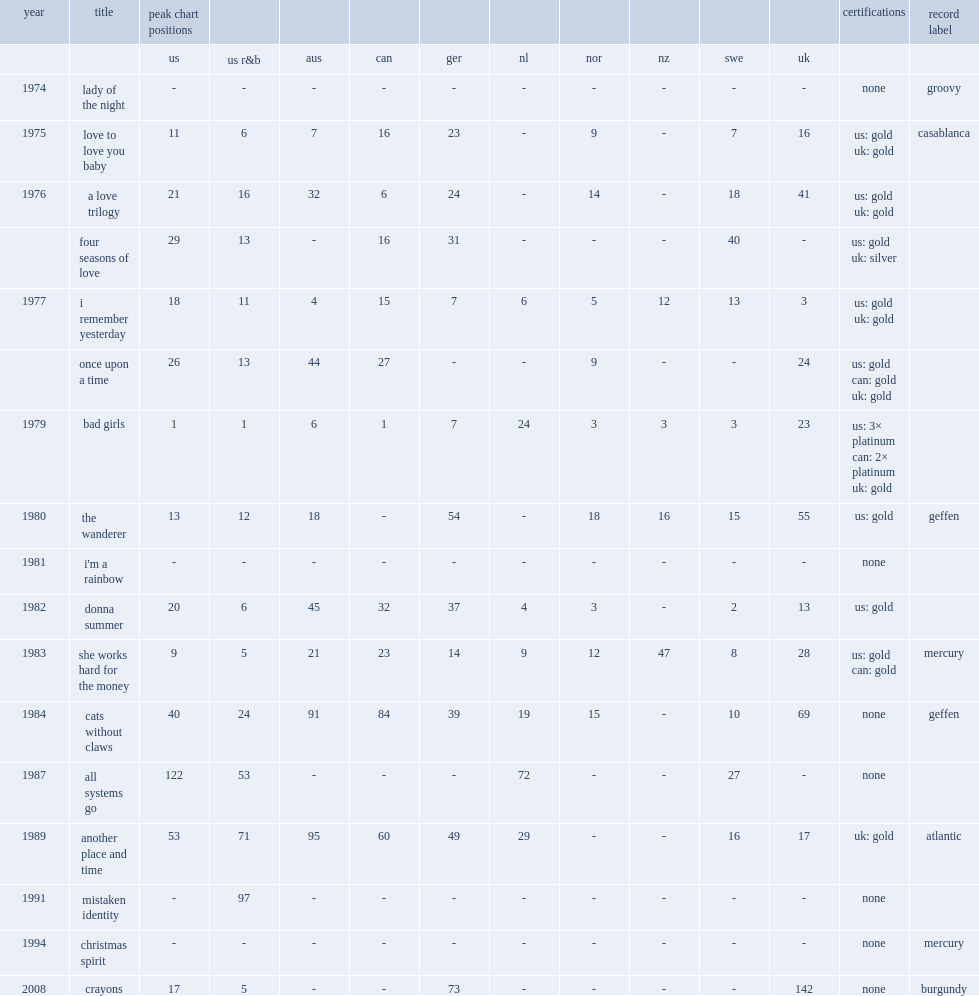When did "she works hard for the money" release? 1983.0. 